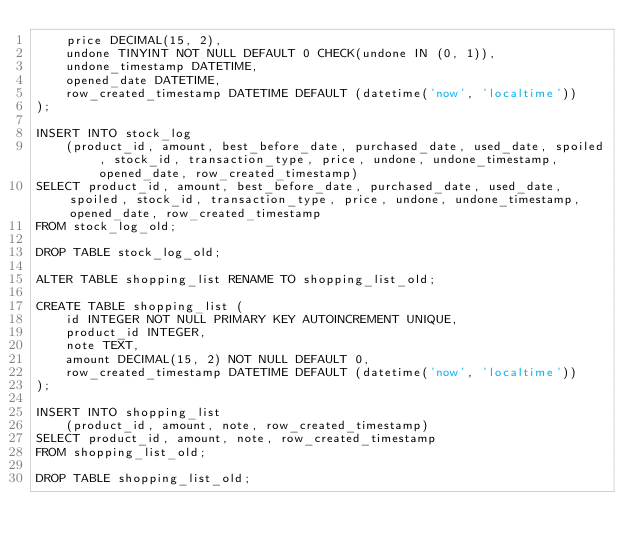Convert code to text. <code><loc_0><loc_0><loc_500><loc_500><_SQL_>	price DECIMAL(15, 2),
	undone TINYINT NOT NULL DEFAULT 0 CHECK(undone IN (0, 1)),
	undone_timestamp DATETIME,
	opened_date DATETIME,
	row_created_timestamp DATETIME DEFAULT (datetime('now', 'localtime'))
);

INSERT INTO stock_log
	(product_id, amount, best_before_date, purchased_date, used_date, spoiled, stock_id, transaction_type, price, undone, undone_timestamp, opened_date, row_created_timestamp)
SELECT product_id, amount, best_before_date, purchased_date, used_date, spoiled, stock_id, transaction_type, price, undone, undone_timestamp, opened_date, row_created_timestamp
FROM stock_log_old;

DROP TABLE stock_log_old;

ALTER TABLE shopping_list RENAME TO shopping_list_old;

CREATE TABLE shopping_list (
	id INTEGER NOT NULL PRIMARY KEY AUTOINCREMENT UNIQUE,
	product_id INTEGER,
	note TEXT,
	amount DECIMAL(15, 2) NOT NULL DEFAULT 0,
	row_created_timestamp DATETIME DEFAULT (datetime('now', 'localtime'))
);

INSERT INTO shopping_list
	(product_id, amount, note, row_created_timestamp)
SELECT product_id, amount, note, row_created_timestamp
FROM shopping_list_old;

DROP TABLE shopping_list_old;
</code> 